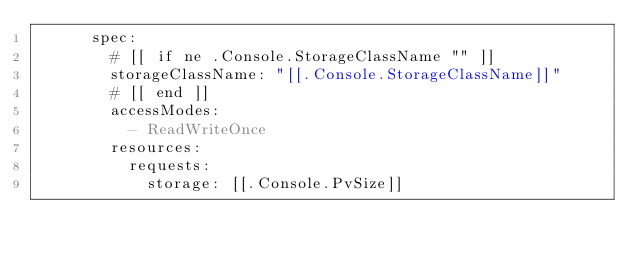Convert code to text. <code><loc_0><loc_0><loc_500><loc_500><_YAML_>      spec:
        # [[ if ne .Console.StorageClassName "" ]]
        storageClassName: "[[.Console.StorageClassName]]"
        # [[ end ]]
        accessModes:
          - ReadWriteOnce
        resources:
          requests:
            storage: [[.Console.PvSize]]

</code> 